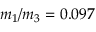Convert formula to latex. <formula><loc_0><loc_0><loc_500><loc_500>m _ { 1 } / m _ { 3 } = 0 . 0 9 7</formula> 